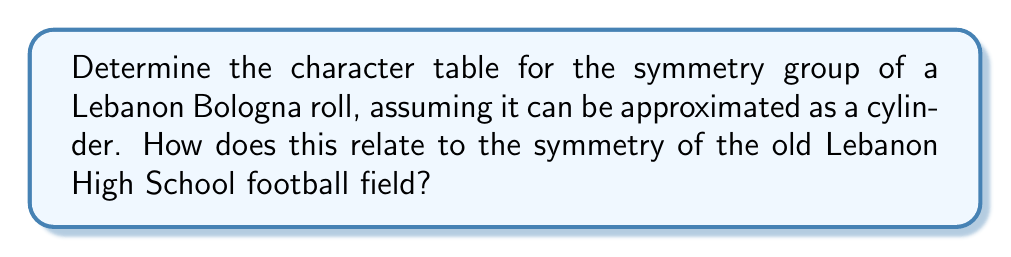Can you answer this question? Let's approach this step-by-step:

1) First, we need to identify the symmetry group of a cylinder (Lebanon Bologna roll). This group is known as $D_{\infty h}$, which consists of:
   - Rotations around the central axis (infinite order)
   - Reflections in planes containing the axis (infinite number)
   - Reflection in a plane perpendicular to the axis
   - Inversion through the center

2) The group $D_{\infty h}$ has five conjugacy classes:
   - $E$: identity
   - $C_{\infty}$: rotations around the axis
   - $\sigma_v$: vertical reflection planes
   - $\sigma_h$: horizontal reflection plane
   - $i$: inversion

3) The character table for $D_{\infty h}$ is:

$$
\begin{array}{c|ccccc}
D_{\infty h} & E & 2C_{\infty}^{\phi} & \infty \sigma_v & \sigma_h & i \\
\hline
A_{1g} & 1 & 1 & 1 & 1 & 1 \\
A_{2g} & 1 & 1 & -1 & 1 & 1 \\
E_{1g} & 2 & 2\cos\phi & 0 & -2 & -2 \\
A_{1u} & 1 & 1 & 1 & -1 & -1 \\
A_{2u} & 1 & 1 & -1 & -1 & -1 \\
E_{1u} & 2 & 2\cos\phi & 0 & 2 & -2
\end{array}
$$

4) The old Lebanon High School football field, being approximately rectangular, would have D2h symmetry, which is a subgroup of D∞h. This means that while the bologna roll has more symmetries, it includes all the symmetries of the football field.

5) The football field symmetries correspond to:
   - Identity (E)
   - 180° rotation around the center (C2)
   - Two reflections across the midfield and goal-to-goal lines (σv)
   - Reflection across the plane of the field (σh)

These are all contained within the symmetries of the Lebanon Bologna roll, showing a connection between these two Lebanon symbols.
Answer: Character table of $D_{\infty h}$ with 6 irreducible representations and 5 conjugacy classes. Football field symmetry (D2h) is a subgroup of bologna roll symmetry (D∞h). 